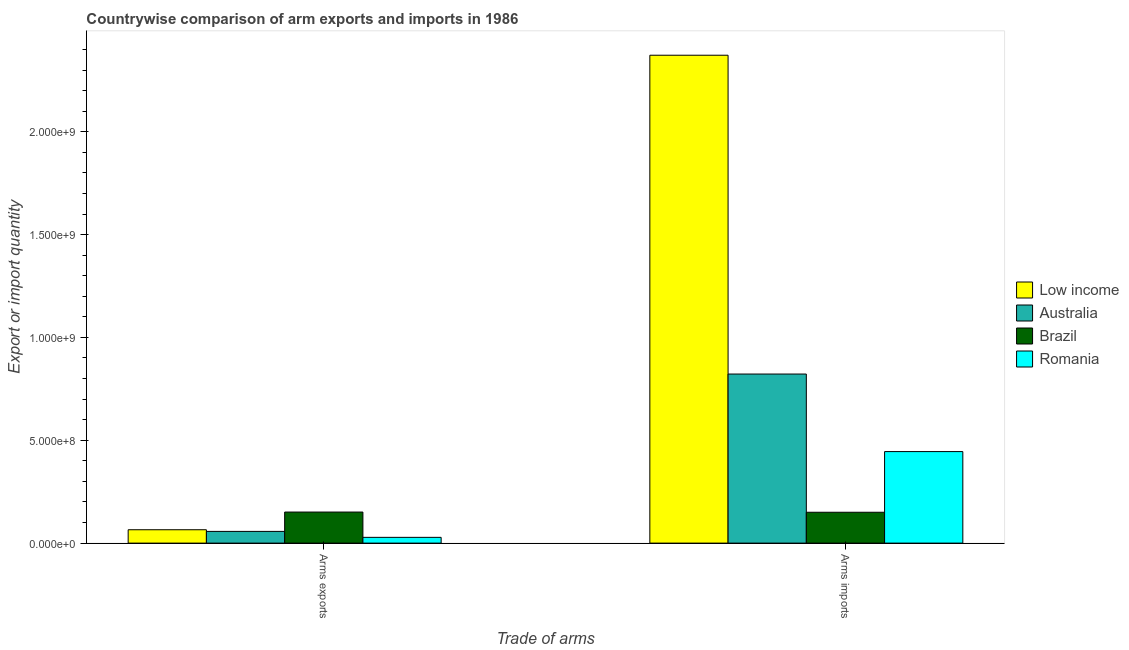How many different coloured bars are there?
Offer a very short reply. 4. How many groups of bars are there?
Your response must be concise. 2. How many bars are there on the 1st tick from the right?
Give a very brief answer. 4. What is the label of the 2nd group of bars from the left?
Your answer should be very brief. Arms imports. What is the arms imports in Romania?
Keep it short and to the point. 4.45e+08. Across all countries, what is the maximum arms exports?
Keep it short and to the point. 1.51e+08. Across all countries, what is the minimum arms exports?
Offer a very short reply. 2.80e+07. In which country was the arms imports maximum?
Make the answer very short. Low income. What is the total arms imports in the graph?
Your response must be concise. 3.79e+09. What is the difference between the arms imports in Low income and that in Brazil?
Make the answer very short. 2.22e+09. What is the difference between the arms exports in Low income and the arms imports in Australia?
Offer a terse response. -7.57e+08. What is the average arms imports per country?
Give a very brief answer. 9.47e+08. What is the difference between the arms exports and arms imports in Low income?
Your response must be concise. -2.31e+09. What is the ratio of the arms exports in Low income to that in Brazil?
Make the answer very short. 0.43. Is the arms exports in Romania less than that in Low income?
Provide a succinct answer. Yes. In how many countries, is the arms exports greater than the average arms exports taken over all countries?
Your answer should be compact. 1. How many bars are there?
Ensure brevity in your answer.  8. Does the graph contain any zero values?
Provide a succinct answer. No. Where does the legend appear in the graph?
Keep it short and to the point. Center right. What is the title of the graph?
Keep it short and to the point. Countrywise comparison of arm exports and imports in 1986. What is the label or title of the X-axis?
Provide a succinct answer. Trade of arms. What is the label or title of the Y-axis?
Your response must be concise. Export or import quantity. What is the Export or import quantity in Low income in Arms exports?
Provide a succinct answer. 6.50e+07. What is the Export or import quantity of Australia in Arms exports?
Provide a short and direct response. 5.70e+07. What is the Export or import quantity of Brazil in Arms exports?
Your response must be concise. 1.51e+08. What is the Export or import quantity of Romania in Arms exports?
Offer a terse response. 2.80e+07. What is the Export or import quantity of Low income in Arms imports?
Offer a terse response. 2.37e+09. What is the Export or import quantity of Australia in Arms imports?
Provide a succinct answer. 8.22e+08. What is the Export or import quantity in Brazil in Arms imports?
Provide a short and direct response. 1.50e+08. What is the Export or import quantity in Romania in Arms imports?
Keep it short and to the point. 4.45e+08. Across all Trade of arms, what is the maximum Export or import quantity of Low income?
Give a very brief answer. 2.37e+09. Across all Trade of arms, what is the maximum Export or import quantity of Australia?
Keep it short and to the point. 8.22e+08. Across all Trade of arms, what is the maximum Export or import quantity in Brazil?
Provide a short and direct response. 1.51e+08. Across all Trade of arms, what is the maximum Export or import quantity of Romania?
Your answer should be very brief. 4.45e+08. Across all Trade of arms, what is the minimum Export or import quantity in Low income?
Ensure brevity in your answer.  6.50e+07. Across all Trade of arms, what is the minimum Export or import quantity of Australia?
Make the answer very short. 5.70e+07. Across all Trade of arms, what is the minimum Export or import quantity of Brazil?
Offer a very short reply. 1.50e+08. Across all Trade of arms, what is the minimum Export or import quantity of Romania?
Your answer should be very brief. 2.80e+07. What is the total Export or import quantity of Low income in the graph?
Your answer should be compact. 2.44e+09. What is the total Export or import quantity of Australia in the graph?
Your answer should be compact. 8.79e+08. What is the total Export or import quantity of Brazil in the graph?
Your answer should be very brief. 3.01e+08. What is the total Export or import quantity of Romania in the graph?
Your answer should be very brief. 4.73e+08. What is the difference between the Export or import quantity in Low income in Arms exports and that in Arms imports?
Make the answer very short. -2.31e+09. What is the difference between the Export or import quantity in Australia in Arms exports and that in Arms imports?
Your response must be concise. -7.65e+08. What is the difference between the Export or import quantity in Romania in Arms exports and that in Arms imports?
Give a very brief answer. -4.17e+08. What is the difference between the Export or import quantity of Low income in Arms exports and the Export or import quantity of Australia in Arms imports?
Give a very brief answer. -7.57e+08. What is the difference between the Export or import quantity in Low income in Arms exports and the Export or import quantity in Brazil in Arms imports?
Keep it short and to the point. -8.50e+07. What is the difference between the Export or import quantity in Low income in Arms exports and the Export or import quantity in Romania in Arms imports?
Your response must be concise. -3.80e+08. What is the difference between the Export or import quantity in Australia in Arms exports and the Export or import quantity in Brazil in Arms imports?
Your response must be concise. -9.30e+07. What is the difference between the Export or import quantity of Australia in Arms exports and the Export or import quantity of Romania in Arms imports?
Keep it short and to the point. -3.88e+08. What is the difference between the Export or import quantity of Brazil in Arms exports and the Export or import quantity of Romania in Arms imports?
Your response must be concise. -2.94e+08. What is the average Export or import quantity in Low income per Trade of arms?
Keep it short and to the point. 1.22e+09. What is the average Export or import quantity in Australia per Trade of arms?
Provide a short and direct response. 4.40e+08. What is the average Export or import quantity of Brazil per Trade of arms?
Keep it short and to the point. 1.50e+08. What is the average Export or import quantity of Romania per Trade of arms?
Your response must be concise. 2.36e+08. What is the difference between the Export or import quantity in Low income and Export or import quantity in Australia in Arms exports?
Your response must be concise. 8.00e+06. What is the difference between the Export or import quantity of Low income and Export or import quantity of Brazil in Arms exports?
Keep it short and to the point. -8.60e+07. What is the difference between the Export or import quantity of Low income and Export or import quantity of Romania in Arms exports?
Your answer should be compact. 3.70e+07. What is the difference between the Export or import quantity in Australia and Export or import quantity in Brazil in Arms exports?
Offer a very short reply. -9.40e+07. What is the difference between the Export or import quantity of Australia and Export or import quantity of Romania in Arms exports?
Offer a terse response. 2.90e+07. What is the difference between the Export or import quantity in Brazil and Export or import quantity in Romania in Arms exports?
Provide a succinct answer. 1.23e+08. What is the difference between the Export or import quantity of Low income and Export or import quantity of Australia in Arms imports?
Offer a very short reply. 1.55e+09. What is the difference between the Export or import quantity of Low income and Export or import quantity of Brazil in Arms imports?
Make the answer very short. 2.22e+09. What is the difference between the Export or import quantity in Low income and Export or import quantity in Romania in Arms imports?
Provide a short and direct response. 1.93e+09. What is the difference between the Export or import quantity of Australia and Export or import quantity of Brazil in Arms imports?
Provide a short and direct response. 6.72e+08. What is the difference between the Export or import quantity of Australia and Export or import quantity of Romania in Arms imports?
Provide a succinct answer. 3.77e+08. What is the difference between the Export or import quantity in Brazil and Export or import quantity in Romania in Arms imports?
Provide a succinct answer. -2.95e+08. What is the ratio of the Export or import quantity in Low income in Arms exports to that in Arms imports?
Give a very brief answer. 0.03. What is the ratio of the Export or import quantity in Australia in Arms exports to that in Arms imports?
Provide a succinct answer. 0.07. What is the ratio of the Export or import quantity of Brazil in Arms exports to that in Arms imports?
Keep it short and to the point. 1.01. What is the ratio of the Export or import quantity in Romania in Arms exports to that in Arms imports?
Your answer should be very brief. 0.06. What is the difference between the highest and the second highest Export or import quantity in Low income?
Keep it short and to the point. 2.31e+09. What is the difference between the highest and the second highest Export or import quantity of Australia?
Give a very brief answer. 7.65e+08. What is the difference between the highest and the second highest Export or import quantity of Romania?
Ensure brevity in your answer.  4.17e+08. What is the difference between the highest and the lowest Export or import quantity in Low income?
Keep it short and to the point. 2.31e+09. What is the difference between the highest and the lowest Export or import quantity of Australia?
Offer a very short reply. 7.65e+08. What is the difference between the highest and the lowest Export or import quantity in Brazil?
Keep it short and to the point. 1.00e+06. What is the difference between the highest and the lowest Export or import quantity of Romania?
Offer a terse response. 4.17e+08. 